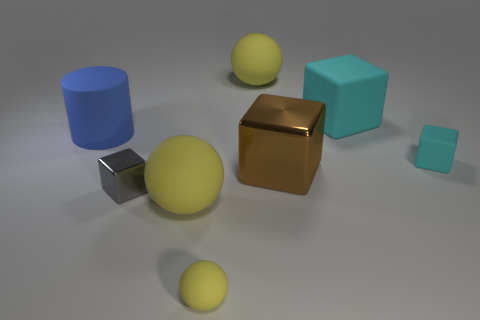How many yellow spheres must be subtracted to get 1 yellow spheres? 2 Add 1 yellow matte balls. How many objects exist? 9 Subtract all cylinders. How many objects are left? 7 Add 4 big rubber cylinders. How many big rubber cylinders exist? 5 Subtract 0 gray cylinders. How many objects are left? 8 Subtract all tiny blocks. Subtract all large brown objects. How many objects are left? 5 Add 8 small gray metallic objects. How many small gray metallic objects are left? 9 